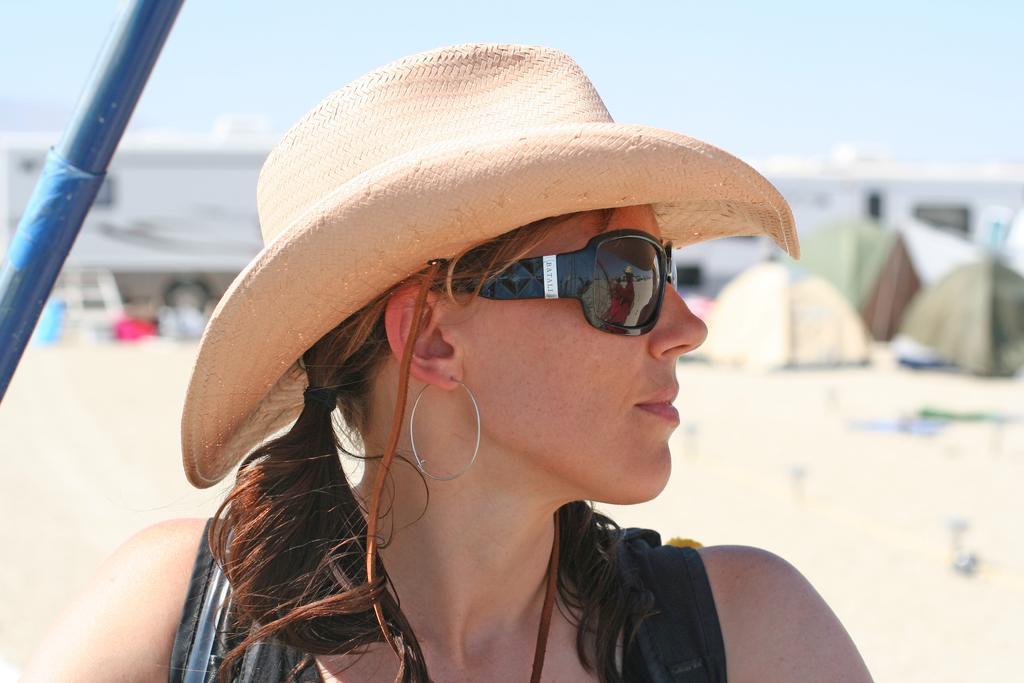Please provide a concise description of this image. In the picture there is a woman in the foreground, she is wearing goggles and a hat. 